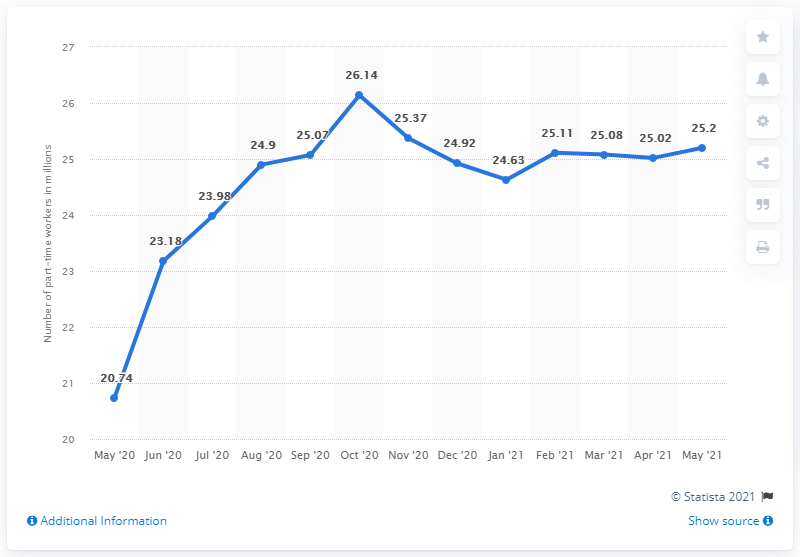List a handful of essential elements in this visual. In May 2021, the United States had approximately 25.2 million part-time employees. As of May 2021, it is estimated that approximately 25.2 million people in the United States were employed on a part-time basis. The number of part-time employees in May 2021 was not higher than the peak value on the graph. 